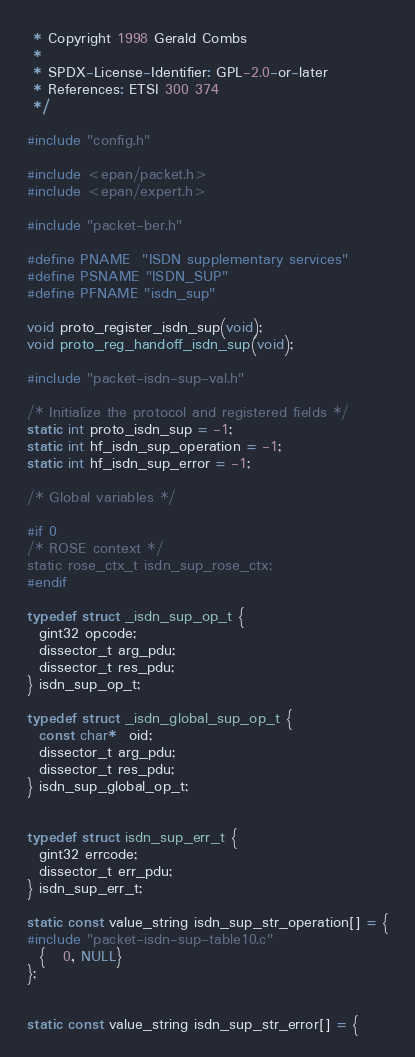<code> <loc_0><loc_0><loc_500><loc_500><_C_> * Copyright 1998 Gerald Combs
 *
 * SPDX-License-Identifier: GPL-2.0-or-later
 * References: ETSI 300 374
 */

#include "config.h"

#include <epan/packet.h>
#include <epan/expert.h>

#include "packet-ber.h"

#define PNAME  "ISDN supplementary services"
#define PSNAME "ISDN_SUP"
#define PFNAME "isdn_sup"

void proto_register_isdn_sup(void);
void proto_reg_handoff_isdn_sup(void);

#include "packet-isdn-sup-val.h"

/* Initialize the protocol and registered fields */
static int proto_isdn_sup = -1;
static int hf_isdn_sup_operation = -1;
static int hf_isdn_sup_error = -1;

/* Global variables */

#if 0
/* ROSE context */
static rose_ctx_t isdn_sup_rose_ctx;
#endif

typedef struct _isdn_sup_op_t {
  gint32 opcode;
  dissector_t arg_pdu;
  dissector_t res_pdu;
} isdn_sup_op_t;

typedef struct _isdn_global_sup_op_t {
  const char*  oid;
  dissector_t arg_pdu;
  dissector_t res_pdu;
} isdn_sup_global_op_t;


typedef struct isdn_sup_err_t {
  gint32 errcode;
  dissector_t err_pdu;
} isdn_sup_err_t;

static const value_string isdn_sup_str_operation[] = {
#include "packet-isdn-sup-table10.c"
  {   0, NULL}
};


static const value_string isdn_sup_str_error[] = {</code> 